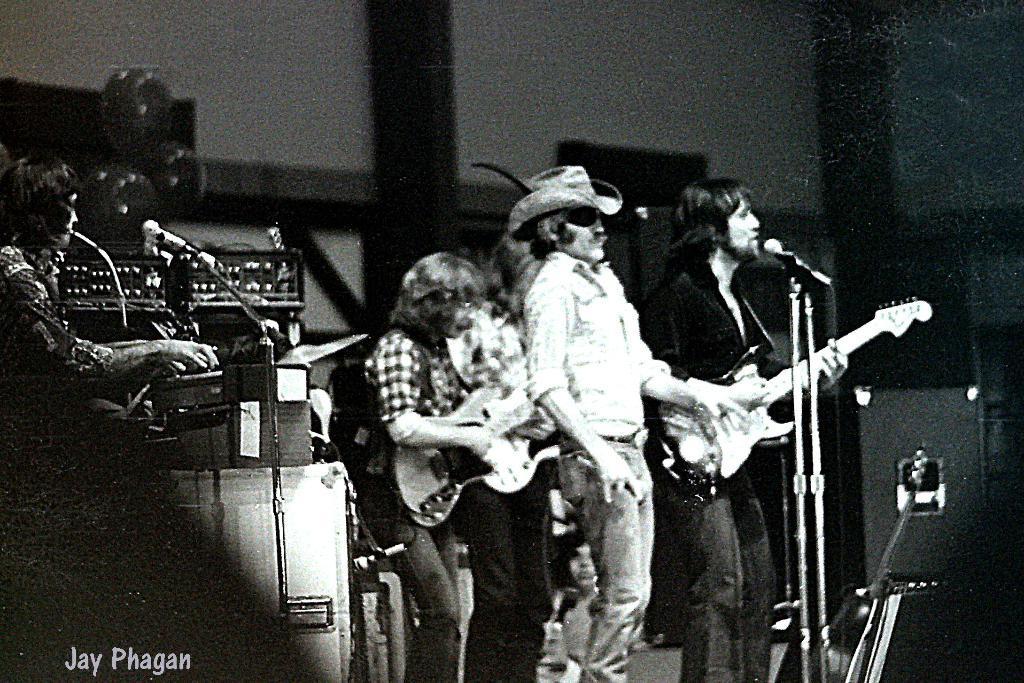Could you give a brief overview of what you see in this image? In this picture there are few people standing and on the right this man is singing and playing the guitar and the woman standing here is playing the guitar and in the background there are some speakers and also woman sitting here 